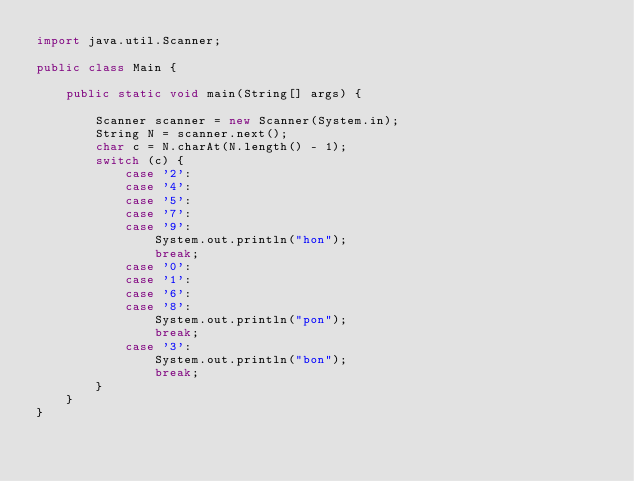Convert code to text. <code><loc_0><loc_0><loc_500><loc_500><_Java_>import java.util.Scanner;

public class Main {

    public static void main(String[] args) {

        Scanner scanner = new Scanner(System.in);
        String N = scanner.next();
        char c = N.charAt(N.length() - 1);
        switch (c) {
            case '2':
            case '4':
            case '5':
            case '7':
            case '9':
                System.out.println("hon");
                break;
            case '0':
            case '1':
            case '6':
            case '8':
                System.out.println("pon");
                break;
            case '3':
                System.out.println("bon");
                break;
        }
    }
}
</code> 